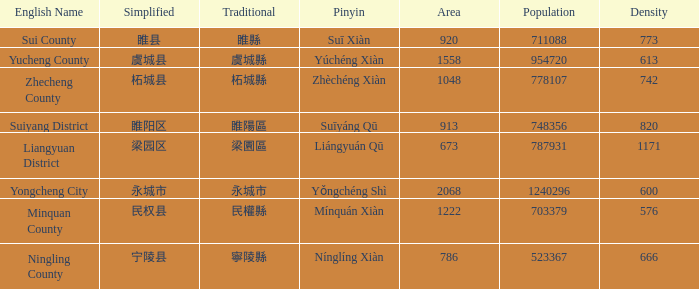How many areas have a population of 703379? 1.0. 